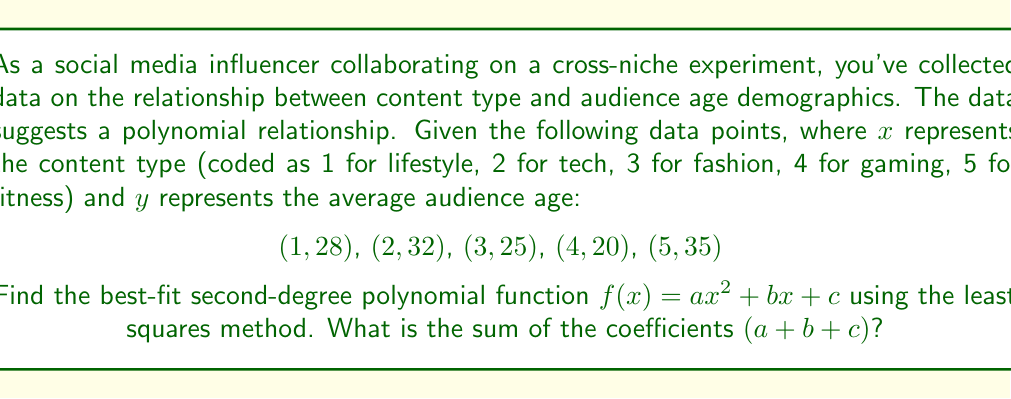Provide a solution to this math problem. To find the best-fit second-degree polynomial, we'll use the least squares method:

1) Set up the system of normal equations:
   $$\begin{cases}
   \sum y = an + b\sum x + c\sum x^2 \\
   \sum xy = a\sum x + b\sum x^2 + c\sum x^3 \\
   \sum x^2y = a\sum x^2 + b\sum x^3 + c\sum x^4
   \end{cases}$$

2) Calculate the sums:
   $n = 5$
   $\sum x = 1 + 2 + 3 + 4 + 5 = 15$
   $\sum x^2 = 1 + 4 + 9 + 16 + 25 = 55$
   $\sum x^3 = 1 + 8 + 27 + 64 + 125 = 225$
   $\sum x^4 = 1 + 16 + 81 + 256 + 625 = 979$
   $\sum y = 28 + 32 + 25 + 20 + 35 = 140$
   $\sum xy = 28 + 64 + 75 + 80 + 175 = 422$
   $\sum x^2y = 28 + 128 + 225 + 320 + 875 = 1576$

3) Substitute into the normal equations:
   $$\begin{cases}
   140 = 5a + 15b + 55c \\
   422 = 15a + 55b + 225c \\
   1576 = 55a + 225b + 979c
   \end{cases}$$

4) Solve this system of equations (using a calculator or computer algebra system):
   $a = 2.5$
   $b = -11.9$
   $c = 37.5$

5) Therefore, the best-fit polynomial is:
   $f(x) = 2.5x^2 - 11.9x + 37.5$

6) The sum of the coefficients is:
   $a + b + c = 2.5 + (-11.9) + 37.5 = 28.1$
Answer: $28.1$ 